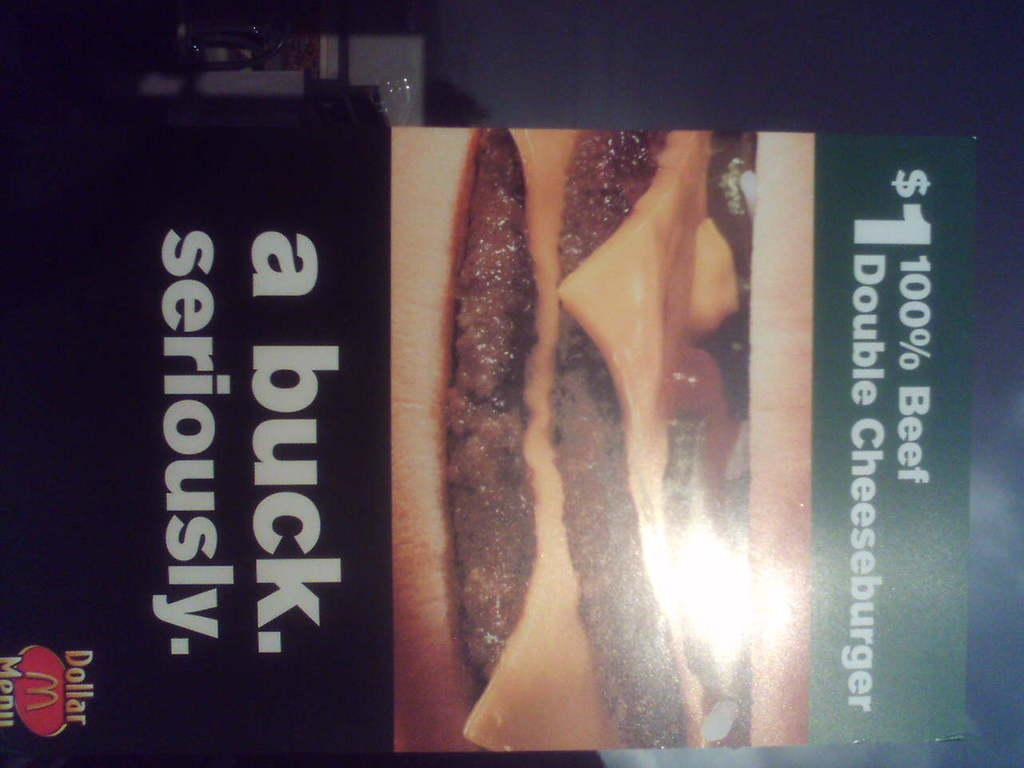What type of food is on the board in the image? There is a burger on the board in the image. What colors are used for the board? The board is cream and black in color. What is the color of the text on the board? The text on the board is white. What can be seen in the background of the image? There is a wall in the background of the image. What type of government is depicted on the board in the image? There is no depiction of a government on the board in the image; it features a burger and text. Is there a desk visible in the image? There is no desk present in the image. 